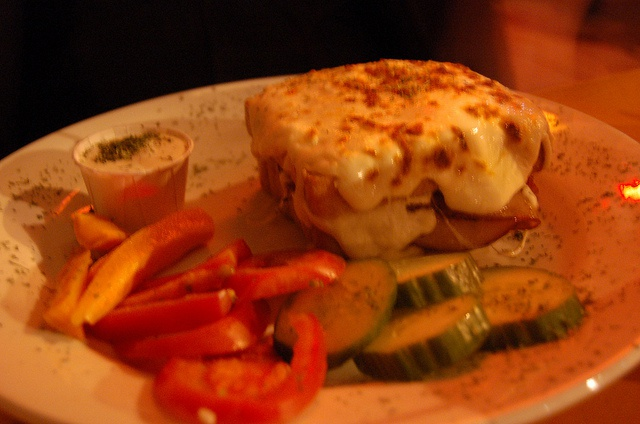Describe the objects in this image and their specific colors. I can see sandwich in black, red, brown, and maroon tones, carrot in black, brown, red, and orange tones, carrot in black, red, and brown tones, and carrot in black, brown, and red tones in this image. 